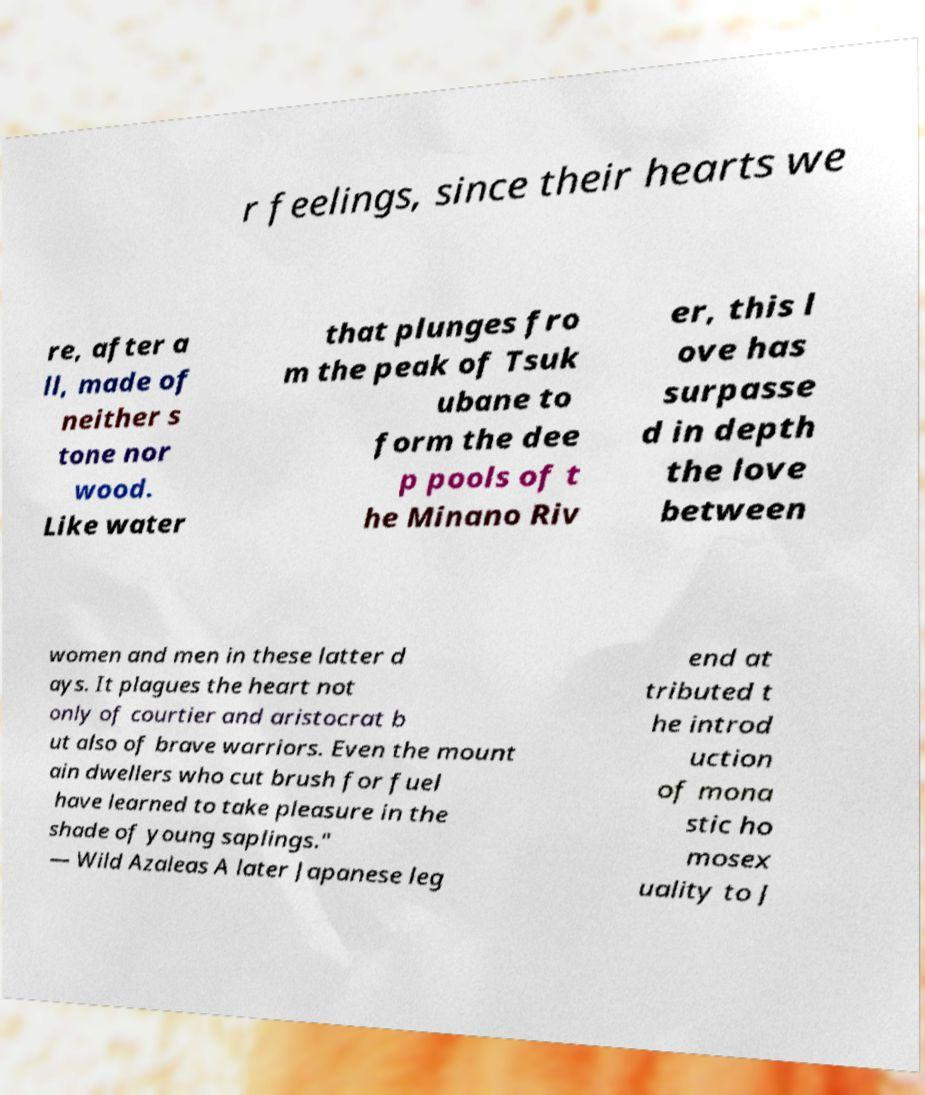I need the written content from this picture converted into text. Can you do that? r feelings, since their hearts we re, after a ll, made of neither s tone nor wood. Like water that plunges fro m the peak of Tsuk ubane to form the dee p pools of t he Minano Riv er, this l ove has surpasse d in depth the love between women and men in these latter d ays. It plagues the heart not only of courtier and aristocrat b ut also of brave warriors. Even the mount ain dwellers who cut brush for fuel have learned to take pleasure in the shade of young saplings." — Wild Azaleas A later Japanese leg end at tributed t he introd uction of mona stic ho mosex uality to J 